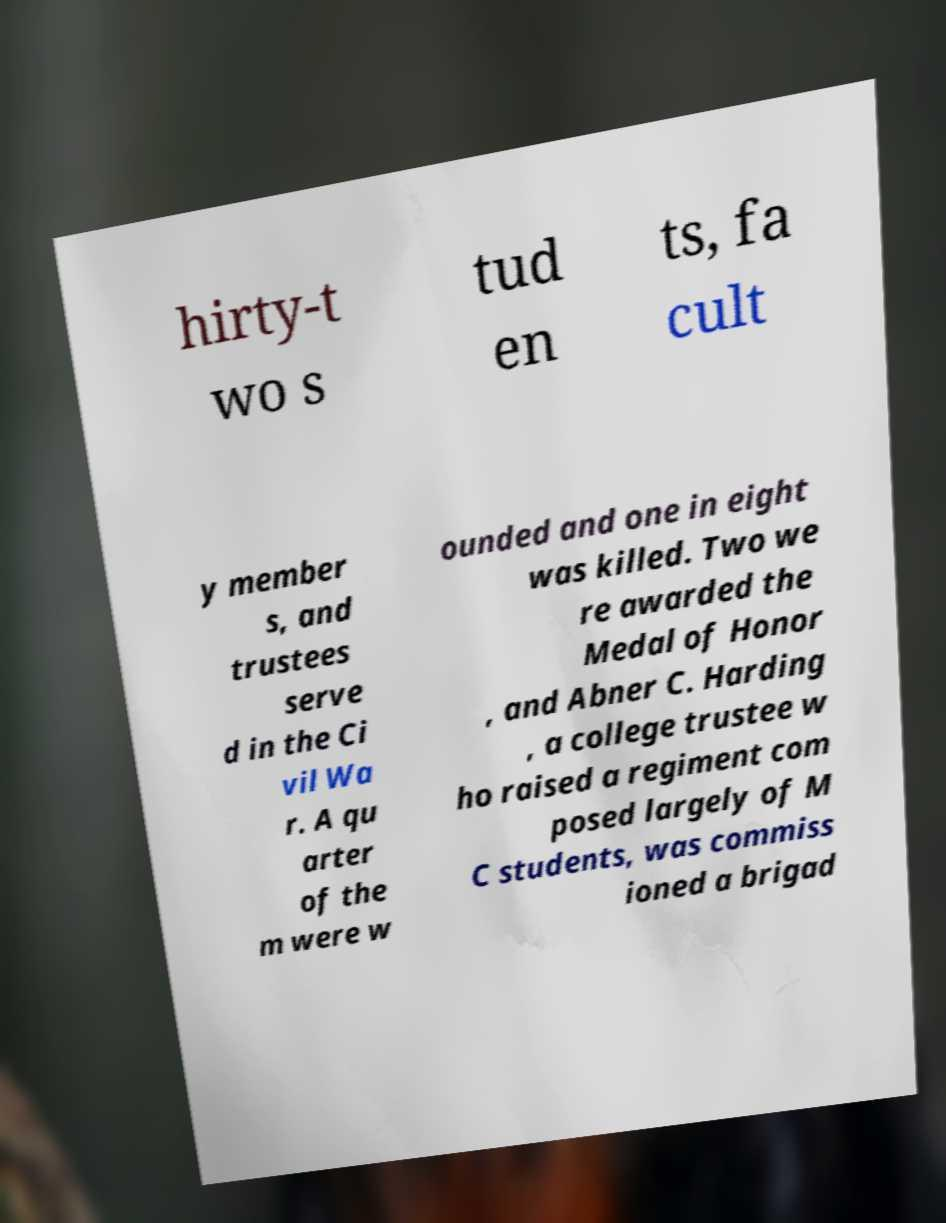Can you read and provide the text displayed in the image?This photo seems to have some interesting text. Can you extract and type it out for me? hirty-t wo s tud en ts, fa cult y member s, and trustees serve d in the Ci vil Wa r. A qu arter of the m were w ounded and one in eight was killed. Two we re awarded the Medal of Honor , and Abner C. Harding , a college trustee w ho raised a regiment com posed largely of M C students, was commiss ioned a brigad 